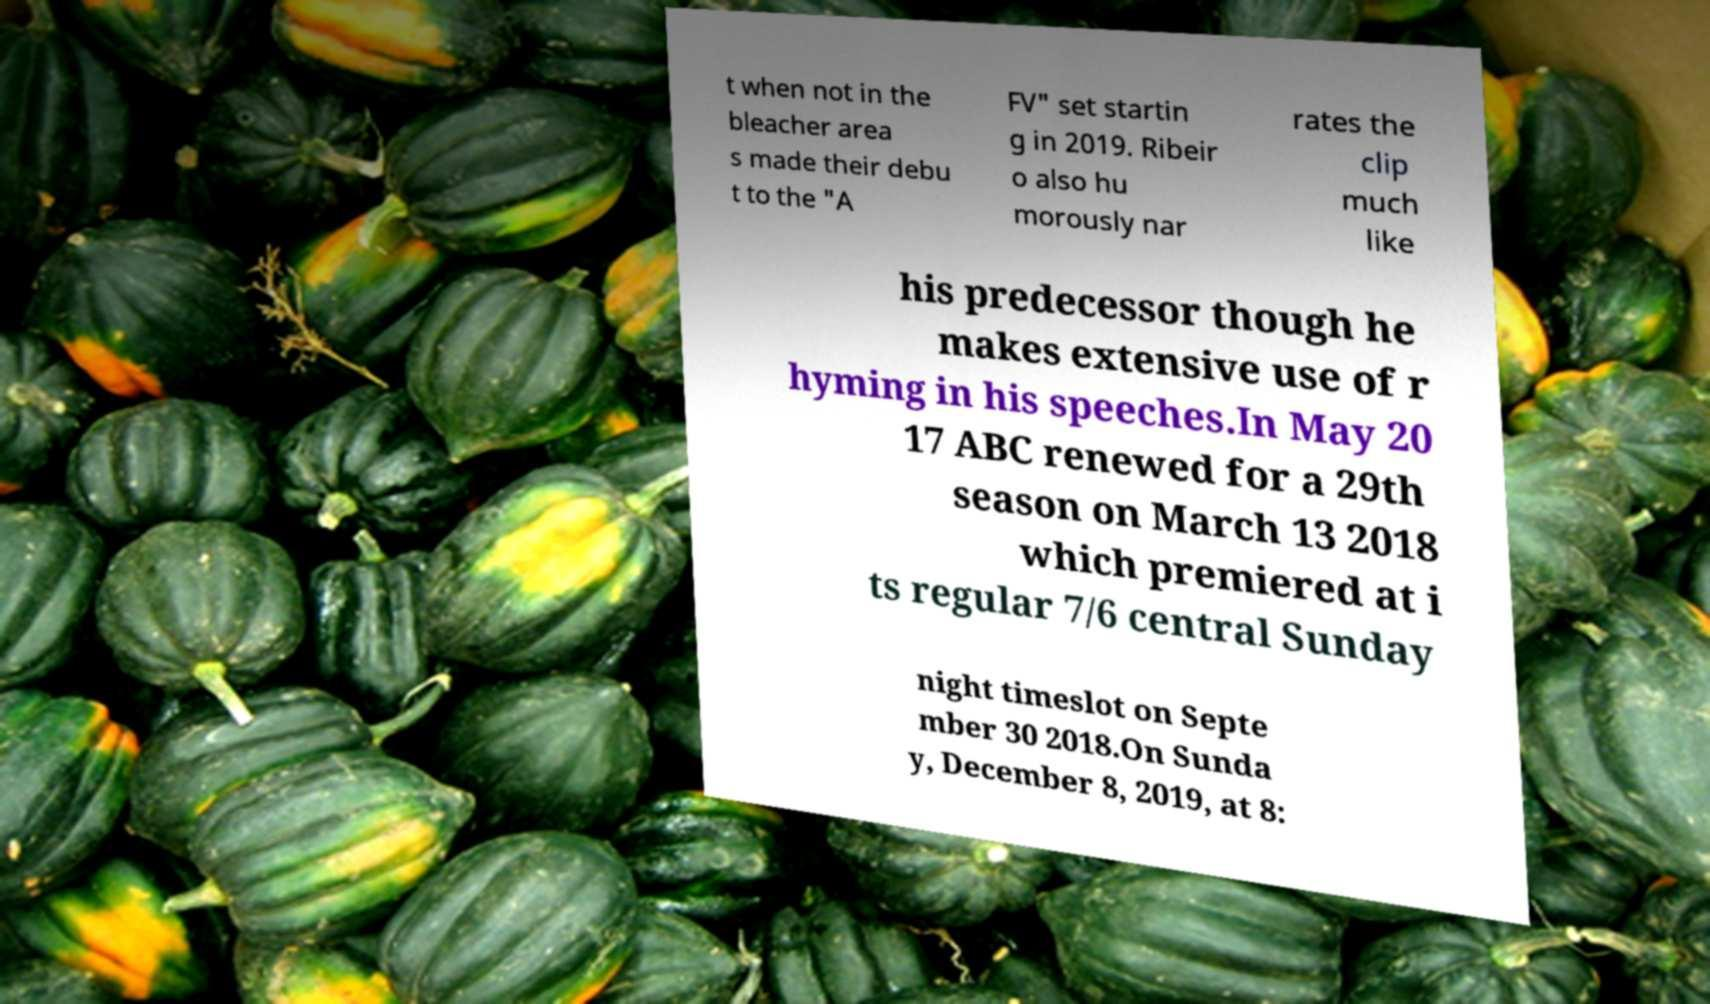Can you read and provide the text displayed in the image?This photo seems to have some interesting text. Can you extract and type it out for me? t when not in the bleacher area s made their debu t to the "A FV" set startin g in 2019. Ribeir o also hu morously nar rates the clip much like his predecessor though he makes extensive use of r hyming in his speeches.In May 20 17 ABC renewed for a 29th season on March 13 2018 which premiered at i ts regular 7/6 central Sunday night timeslot on Septe mber 30 2018.On Sunda y, December 8, 2019, at 8: 